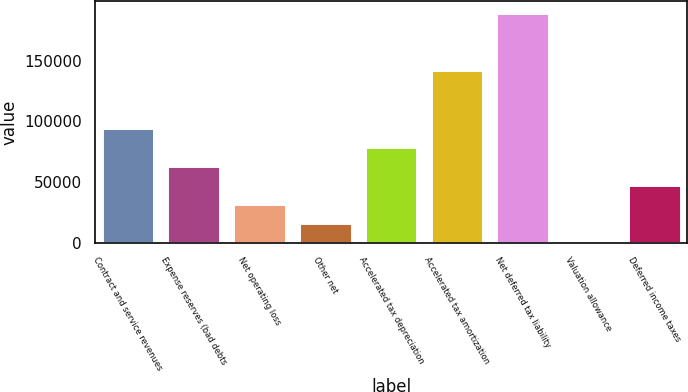Convert chart to OTSL. <chart><loc_0><loc_0><loc_500><loc_500><bar_chart><fcel>Contract and service revenues<fcel>Expense reserves (bad debts<fcel>Net operating loss<fcel>Other net<fcel>Accelerated tax depreciation<fcel>Accelerated tax amortization<fcel>Net deferred tax liability<fcel>Valuation allowance<fcel>Deferred income taxes<nl><fcel>94614.2<fcel>63292.8<fcel>31971.4<fcel>16310.7<fcel>78953.5<fcel>142776<fcel>189758<fcel>650<fcel>47632.1<nl></chart> 